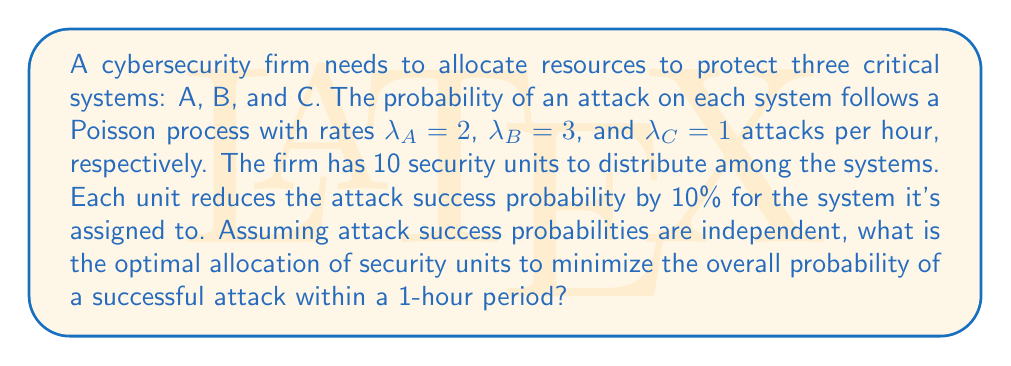Could you help me with this problem? Let's approach this step-by-step:

1) First, we need to understand the probability of a successful attack on each system without protection:
   P(success) = 1 - P(no attacks in 1 hour)
   For a Poisson process: P(no attacks in time t) = e^(-λt)
   So, P(success) = 1 - e^(-λ)

2) For each system:
   System A: P(success) = 1 - e^(-2) ≈ 0.8647
   System B: P(success) = 1 - e^(-3) ≈ 0.9502
   System C: P(success) = 1 - e^(-1) ≈ 0.6321

3) Let x, y, and z be the number of units allocated to A, B, and C respectively.
   The new probabilities of successful attack become:
   P(A) = (1 - e^(-2)) * (1 - 0.1x)
   P(B) = (1 - e^(-3)) * (1 - 0.1y)
   P(C) = (1 - e^(-1)) * (1 - 0.1z)

4) The overall probability of at least one successful attack is:
   P(total) = 1 - (1 - P(A)) * (1 - P(B)) * (1 - P(C))

5) We want to minimize P(total) subject to the constraints:
   x + y + z = 10
   x, y, z ≥ 0 and integers

6) This is a non-linear integer programming problem. We can solve it using dynamic programming or by evaluating all possible integer combinations.

7) Evaluating all combinations, we find the minimum P(total) occurs when:
   x = 3, y = 5, z = 2

8) This allocation gives:
   P(A) ≈ 0.6053
   P(B) ≈ 0.4751
   P(C) ≈ 0.5057
   P(total) ≈ 0.9097
Answer: Optimal allocation: 3 units to System A, 5 units to System B, 2 units to System C. 